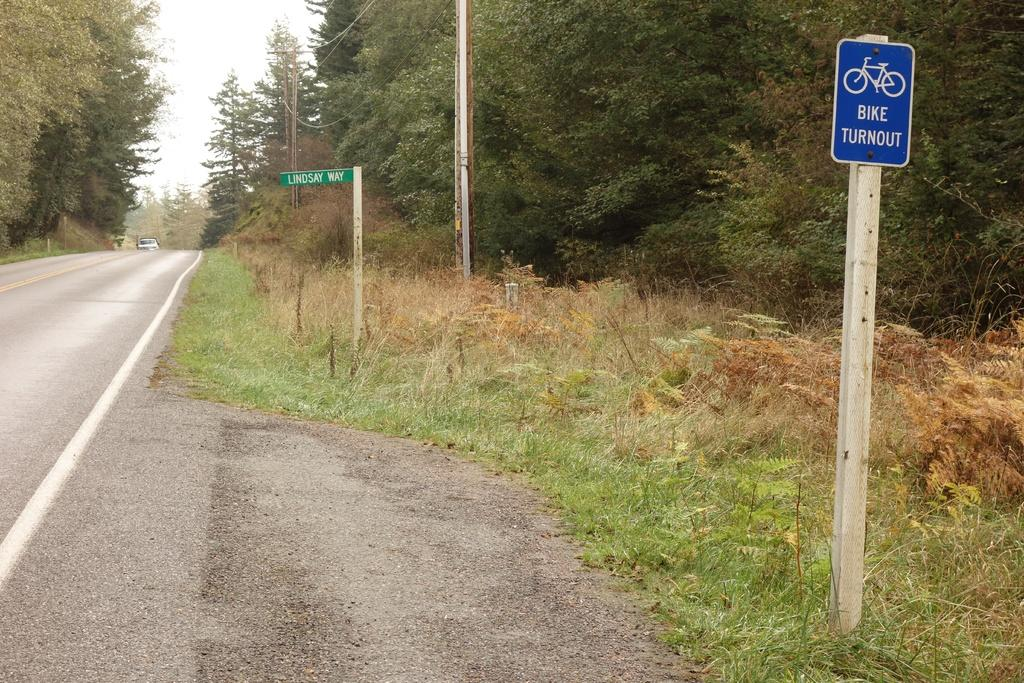<image>
Summarize the visual content of the image. A blue street sign informs people that there is a Bike Turnout. 